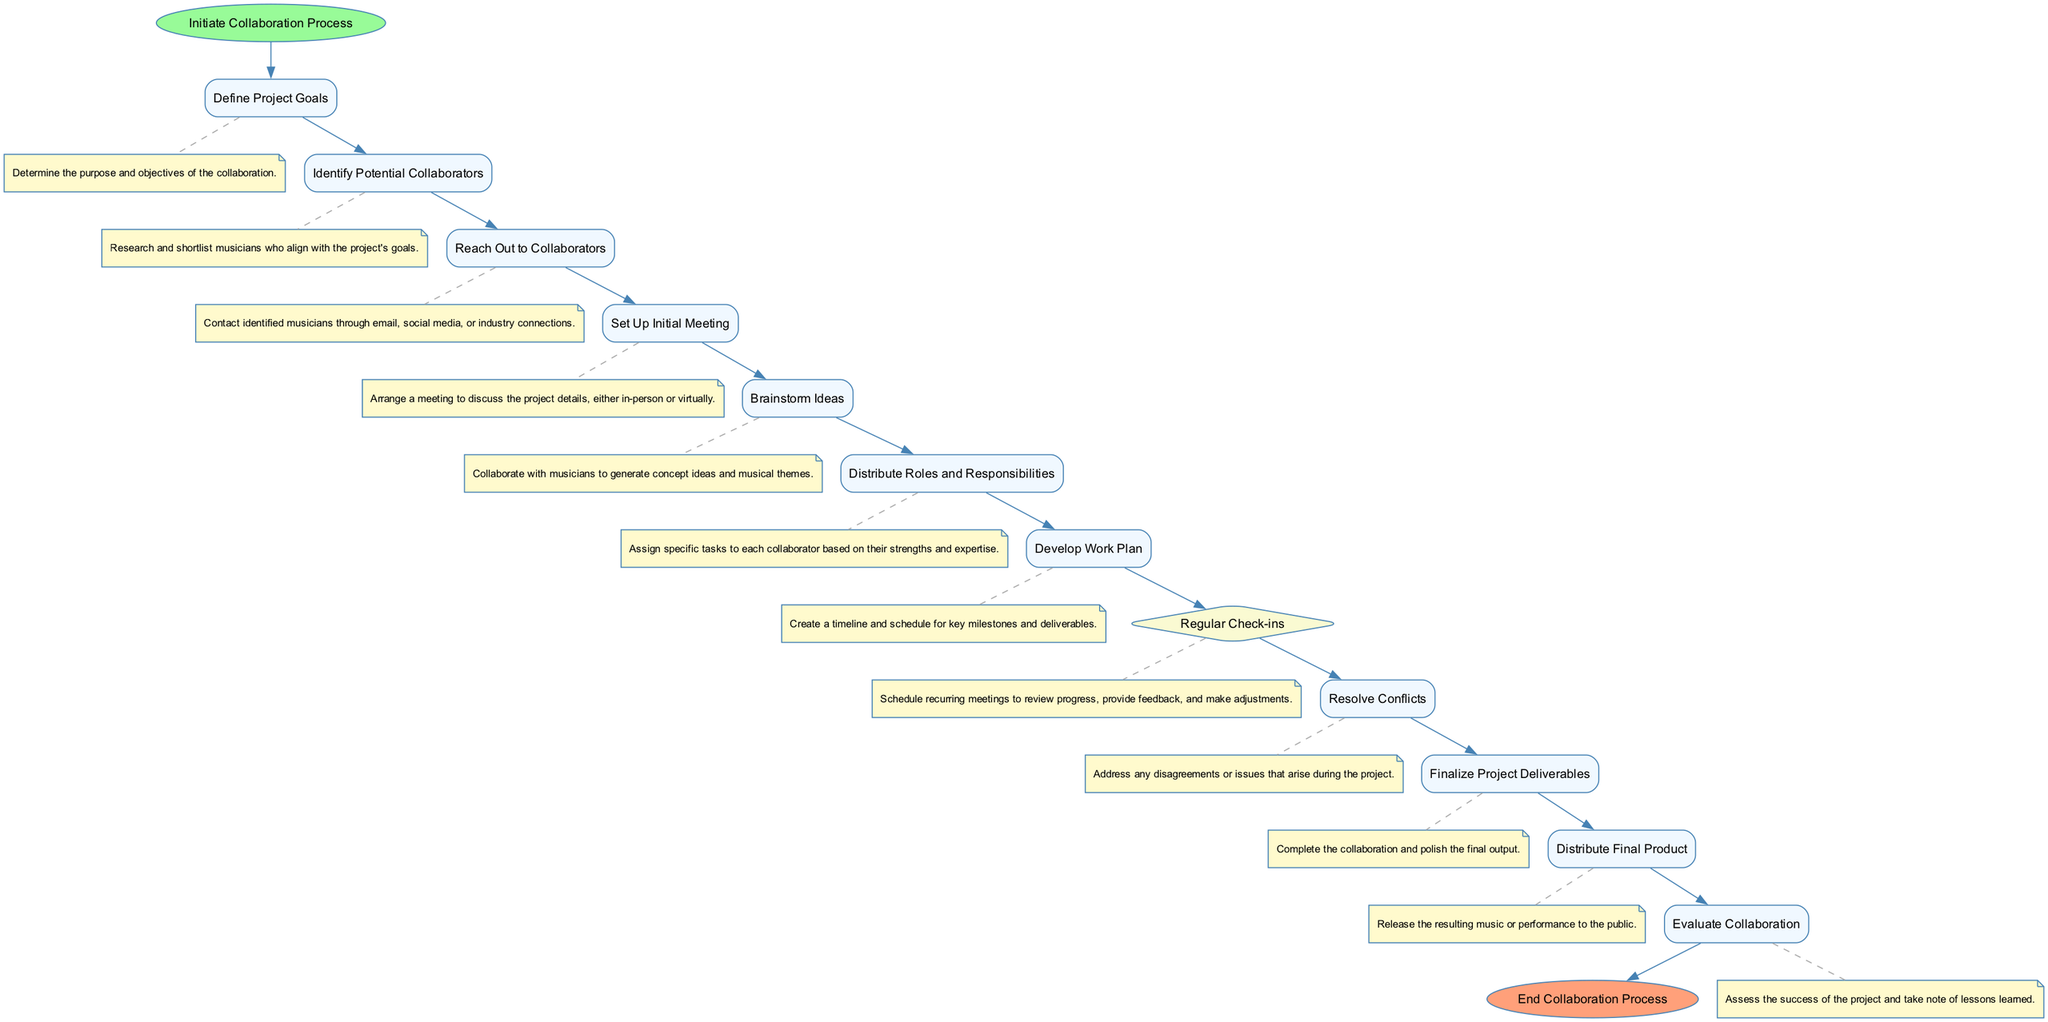What is the first activity in the collaboration process? The first activity mentioned in the diagram is "Define Project Goals," which is directly after the start node.
Answer: Define Project Goals How many activities are there in total? By counting all the nodes classified as activities in the diagram, there are 10 activities total, excluding the start and end nodes.
Answer: 10 What is the last activity before the end of the collaboration process? The last activity connected to the end node is "Distribute Final Product," which indicates the final step of the process before concluding.
Answer: Distribute Final Product Which activity involves addressing disagreements? The activity labeled "Resolve Conflicts" specifically deals with addressing any disagreements or issues that may arise during the project, as shown in the diagram.
Answer: Resolve Conflicts What happens after brainstorming ideas and before finalizing project deliverables? Following "Brainstorm Ideas," the next activity is "Distribute Roles and Responsibilities," which is a crucial step before finalizing the project's output.
Answer: Distribute Roles and Responsibilities What decision is made in the process to ensure regular communication? The decision to hold "Regular Check-ins" is made to ensure ongoing communication and review of progress, as depicted in the diagram.
Answer: Regular Check-ins How is the flow between identifying collaborators and reaching out to them? The flow from "Identify Potential Collaborators" to "Reach Out to Collaborators" directly indicates that after identifying potential collaborators, the next step is to initiate contact with them.
Answer: Reach Out to Collaborators What role does "Evaluate Collaboration" play in the overall process? At the end of the process, "Evaluate Collaboration" serves to assess the project's success and reflect on lessons learned, thus playing a key role in improving future collaborations.
Answer: Evaluate Collaboration 